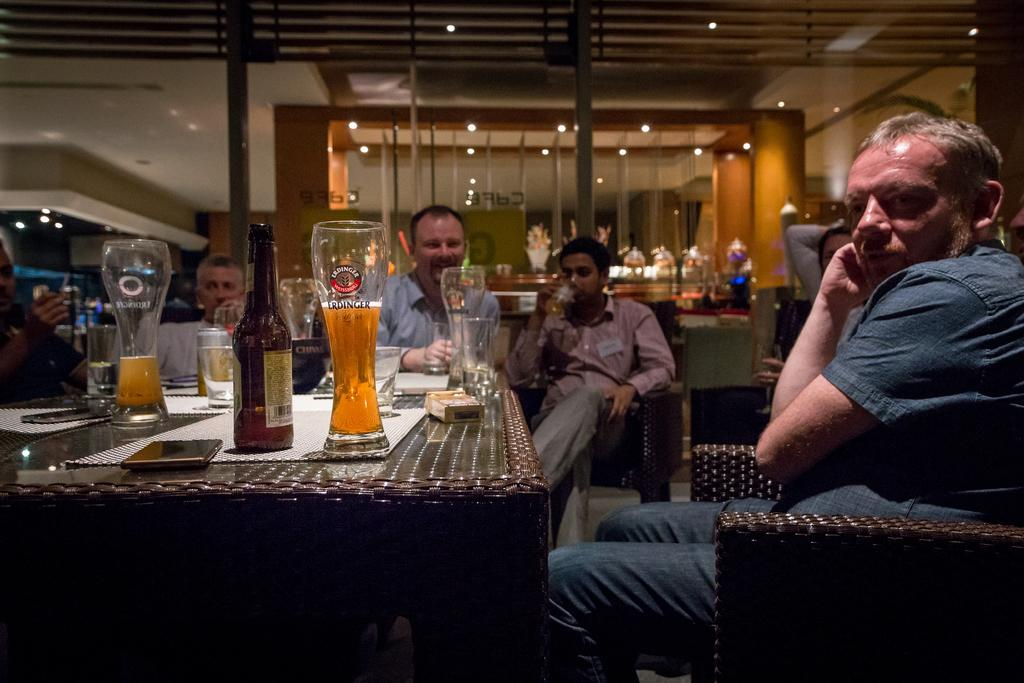Where is the setting of the image? The image is an indoor picture. What are the people in the image doing? The persons in the image are sitting on chairs. What is in front of the persons? There is a table in front of the persons. What objects can be seen on the table? There are glasses, a bottle, a bowl, a mat, a box, and a mobile on the table. What else is visible in the image? There are plants visible in the image. Can you tell me how many donkeys are present in the image? There are no donkeys present in the image. What type of vacation is being enjoyed by the persons in the image? There is no indication of a vacation in the image; it is an indoor setting with people sitting at a table. 